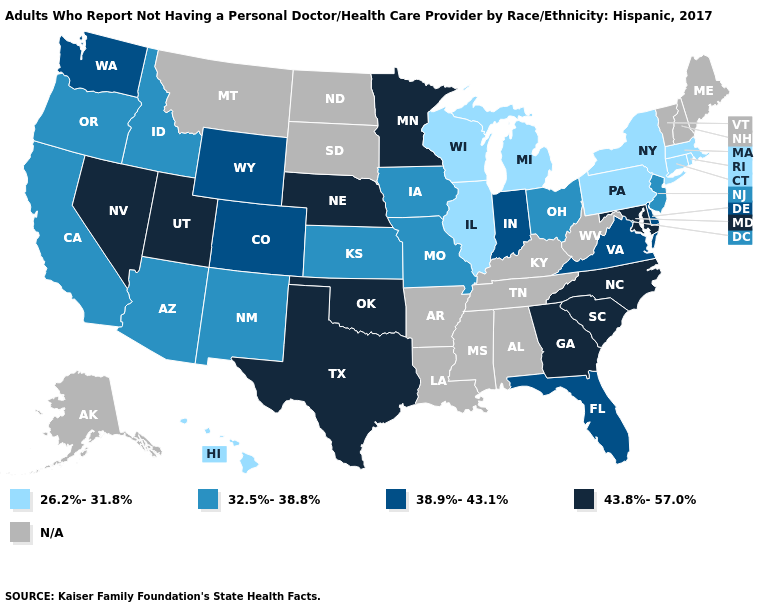What is the highest value in states that border Louisiana?
Be succinct. 43.8%-57.0%. Name the states that have a value in the range N/A?
Concise answer only. Alabama, Alaska, Arkansas, Kentucky, Louisiana, Maine, Mississippi, Montana, New Hampshire, North Dakota, South Dakota, Tennessee, Vermont, West Virginia. Does the first symbol in the legend represent the smallest category?
Short answer required. Yes. What is the value of Hawaii?
Concise answer only. 26.2%-31.8%. Which states hav the highest value in the MidWest?
Be succinct. Minnesota, Nebraska. What is the highest value in the Northeast ?
Quick response, please. 32.5%-38.8%. Does the first symbol in the legend represent the smallest category?
Short answer required. Yes. Among the states that border West Virginia , does Maryland have the highest value?
Be succinct. Yes. Name the states that have a value in the range 38.9%-43.1%?
Give a very brief answer. Colorado, Delaware, Florida, Indiana, Virginia, Washington, Wyoming. Does Hawaii have the lowest value in the West?
Write a very short answer. Yes. Name the states that have a value in the range 32.5%-38.8%?
Be succinct. Arizona, California, Idaho, Iowa, Kansas, Missouri, New Jersey, New Mexico, Ohio, Oregon. Among the states that border Wyoming , does Utah have the highest value?
Concise answer only. Yes. Is the legend a continuous bar?
Answer briefly. No. Name the states that have a value in the range 26.2%-31.8%?
Short answer required. Connecticut, Hawaii, Illinois, Massachusetts, Michigan, New York, Pennsylvania, Rhode Island, Wisconsin. 